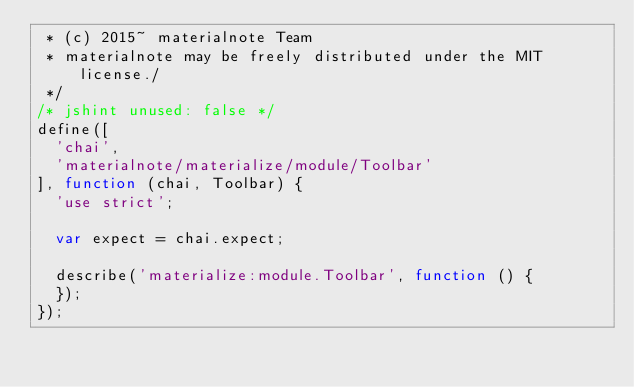Convert code to text. <code><loc_0><loc_0><loc_500><loc_500><_JavaScript_> * (c) 2015~ materialnote Team
 * materialnote may be freely distributed under the MIT license./
 */
/* jshint unused: false */
define([
  'chai',
  'materialnote/materialize/module/Toolbar'
], function (chai, Toolbar) {
  'use strict';

  var expect = chai.expect;

  describe('materialize:module.Toolbar', function () {
  });
});
</code> 